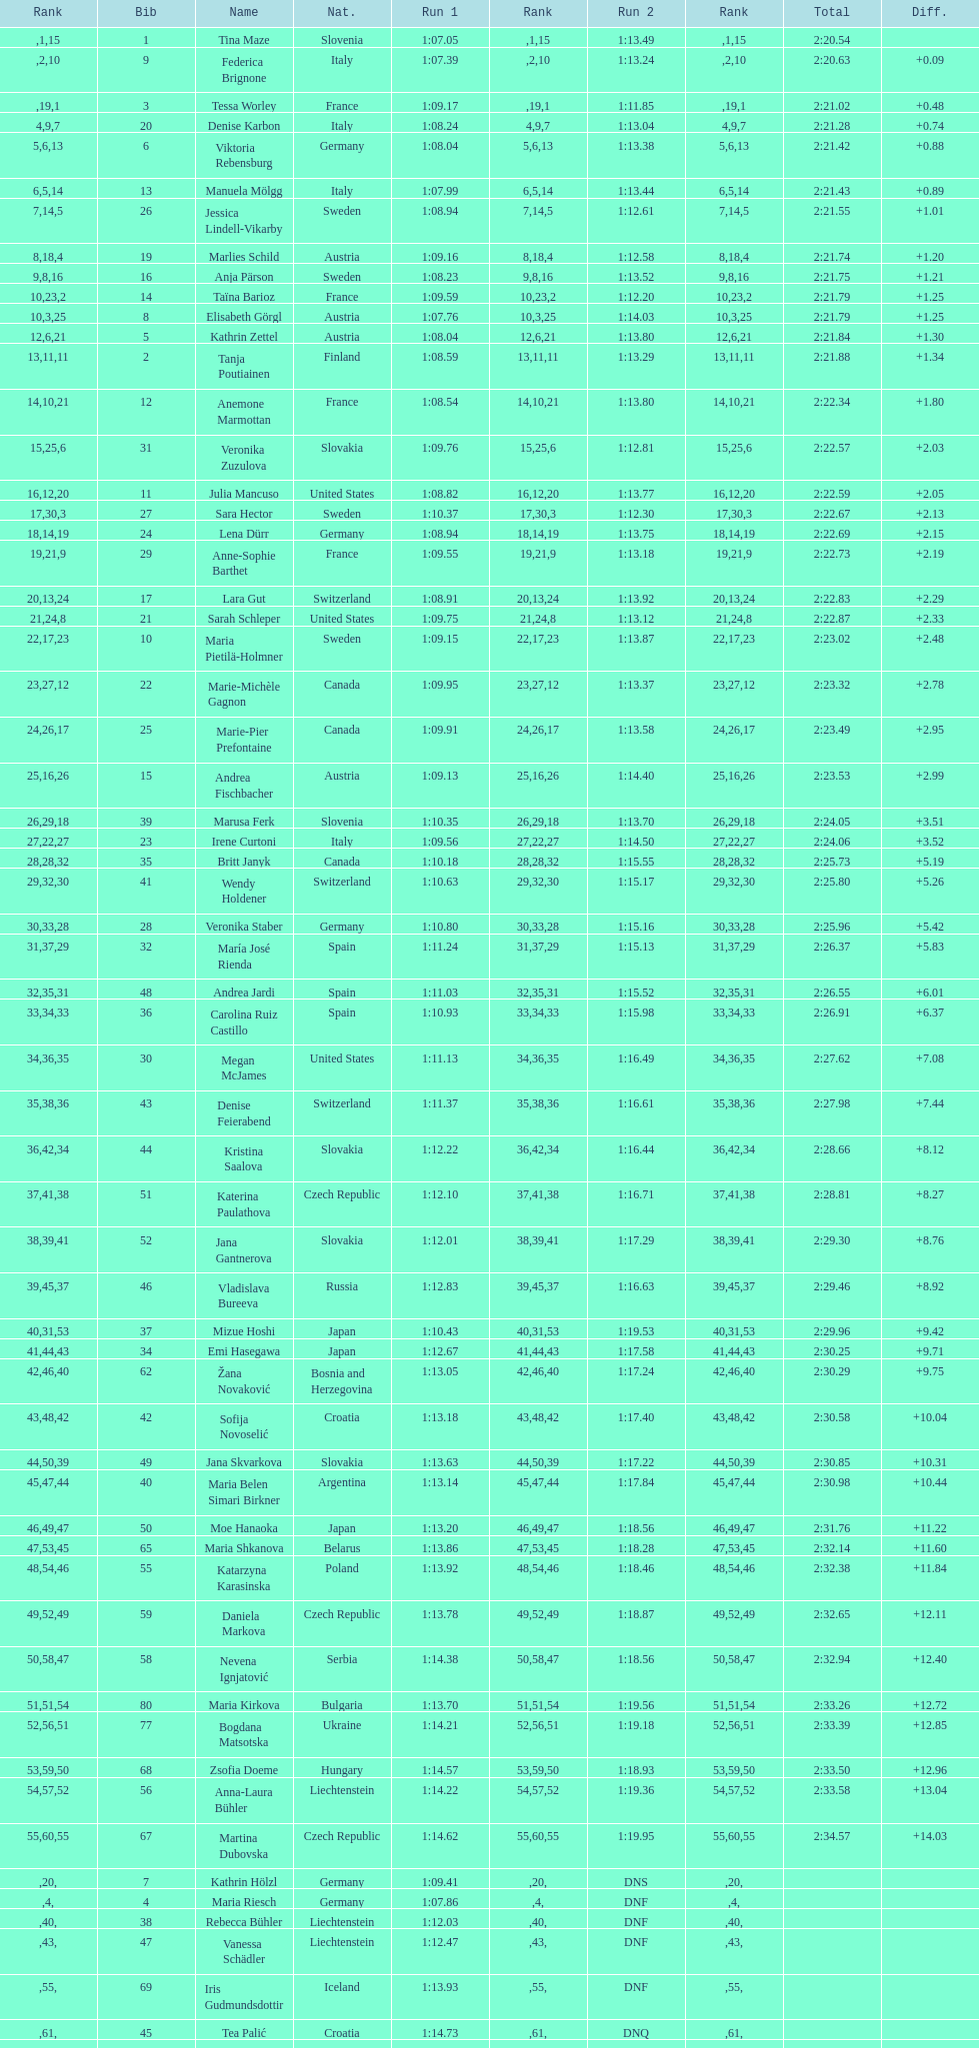What is the last nation to be ranked? Czech Republic. 